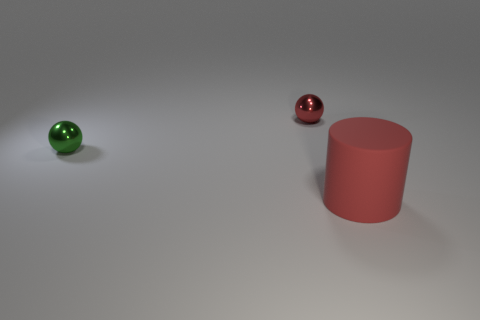Is there any other thing that is made of the same material as the tiny green thing?
Your answer should be very brief. Yes. The other shiny object that is the same shape as the small red shiny thing is what size?
Your answer should be very brief. Small. There is a thing that is on the left side of the big thing and to the right of the small green metallic thing; what material is it made of?
Your answer should be very brief. Metal. Do the metallic thing behind the small green sphere and the matte thing have the same color?
Give a very brief answer. Yes. There is a matte object; is its color the same as the metallic thing on the right side of the tiny green object?
Keep it short and to the point. Yes. There is a large thing; are there any matte objects in front of it?
Your answer should be very brief. No. Is the material of the small red ball the same as the green thing?
Keep it short and to the point. Yes. There is a red object that is the same size as the green object; what is it made of?
Provide a short and direct response. Metal. How many objects are things behind the large red cylinder or large gray matte cubes?
Your answer should be very brief. 2. Are there an equal number of green shiny objects on the left side of the green object and big red rubber things?
Your response must be concise. No. 